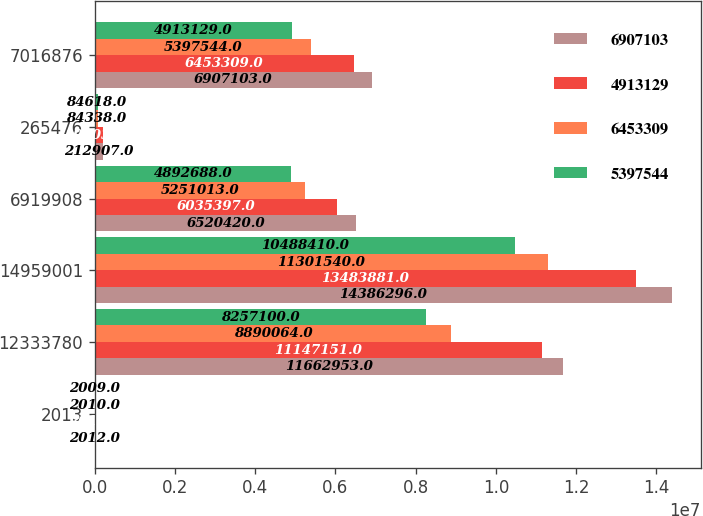Convert chart to OTSL. <chart><loc_0><loc_0><loc_500><loc_500><stacked_bar_chart><ecel><fcel>2013<fcel>12333780<fcel>14959001<fcel>6919908<fcel>265476<fcel>7016876<nl><fcel>6.9071e+06<fcel>2012<fcel>1.1663e+07<fcel>1.43863e+07<fcel>6.52042e+06<fcel>212907<fcel>6.9071e+06<nl><fcel>4.91313e+06<fcel>2011<fcel>1.11472e+07<fcel>1.34839e+07<fcel>6.0354e+06<fcel>195030<fcel>6.45331e+06<nl><fcel>6.45331e+06<fcel>2010<fcel>8.89006e+06<fcel>1.13015e+07<fcel>5.25101e+06<fcel>84338<fcel>5.39754e+06<nl><fcel>5.39754e+06<fcel>2009<fcel>8.2571e+06<fcel>1.04884e+07<fcel>4.89269e+06<fcel>84618<fcel>4.91313e+06<nl></chart> 